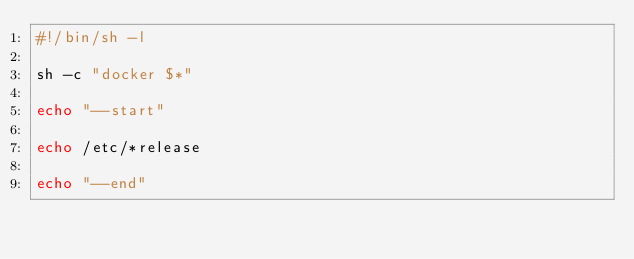<code> <loc_0><loc_0><loc_500><loc_500><_Bash_>#!/bin/sh -l

sh -c "docker $*"

echo "--start"

echo /etc/*release

echo "--end"</code> 